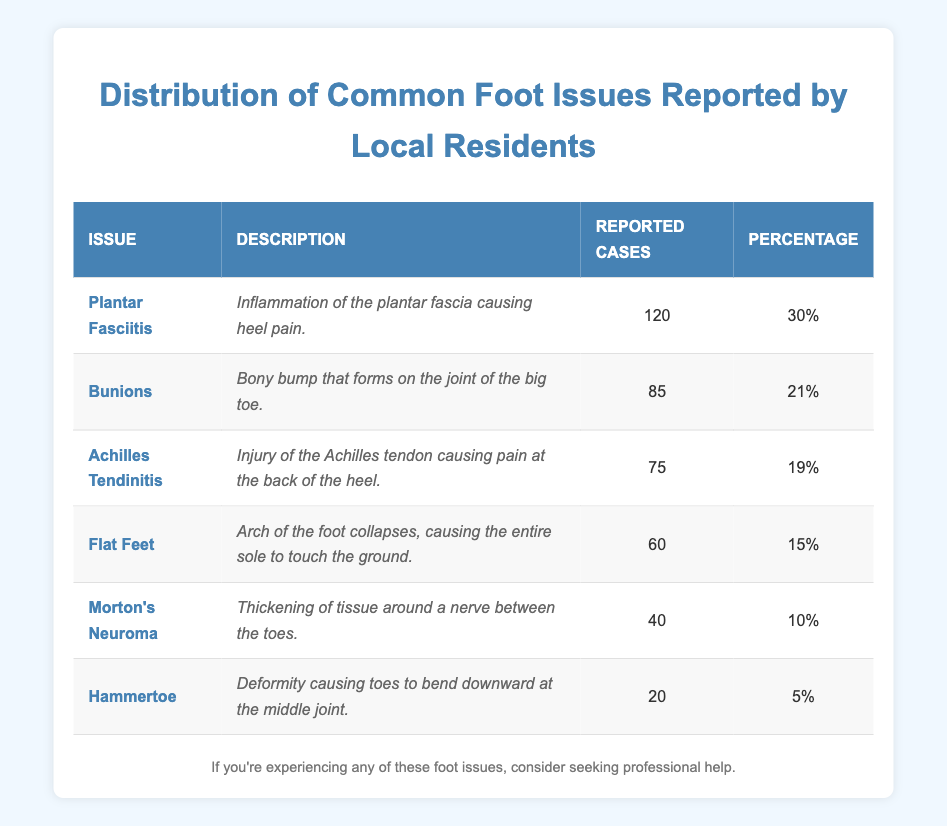What is the most reported foot issue among local residents? The table lists the foot issues along with the reported cases. The first row indicates that Plantar Fasciitis has 120 reported cases, which is the highest number compared to other issues.
Answer: Plantar Fasciitis How many reported cases are there for Bunions? The table shows that there are 85 reported cases for Bunions listed in the row corresponding to this issue.
Answer: 85 What percentage of respondents reported having Flat Feet? According to the table, Flat Feet has an associated percentage of 15% as shown in the table row for this issue.
Answer: 15% Is Morton's Neuroma one of the top three common foot issues reported? To determine this, we look at the reported cases. Morton's Neuroma has 40 reported cases, which ranks it fifth overall, as it has fewer cases than three other issues (Plantar Fasciitis, Bunions, and Achilles Tendinitis).
Answer: No What is the total number of reported cases for all foot issues listed in the table? The total is calculated by adding the reported cases for each issue: 120 + 85 + 75 + 60 + 40 + 20 = 400, resulting in a total of 400 reported cases.
Answer: 400 What is the percentage difference between the second most reported foot issue and the least? Bunions are the second most reported issue with 21%, and Hammertoe is the least reported with 5%. The difference is 21% - 5% = 16%.
Answer: 16% How many more cases were reported for Achilles Tendinitis compared to Hammertoe? Achilles Tendinitis has 75 reported cases, while Hammertoe has 20. The difference is 75 - 20 = 55.
Answer: 55 What is the average percentage of reported cases for the top three issues? The top three issues are Plantar Fasciitis (30%), Bunions (21%), and Achilles Tendinitis (19%). The sum of these percentages is 30 + 21 + 19 = 70, and dividing by 3 gives us an average of 70 / 3 = 23.33%.
Answer: 23.33% 